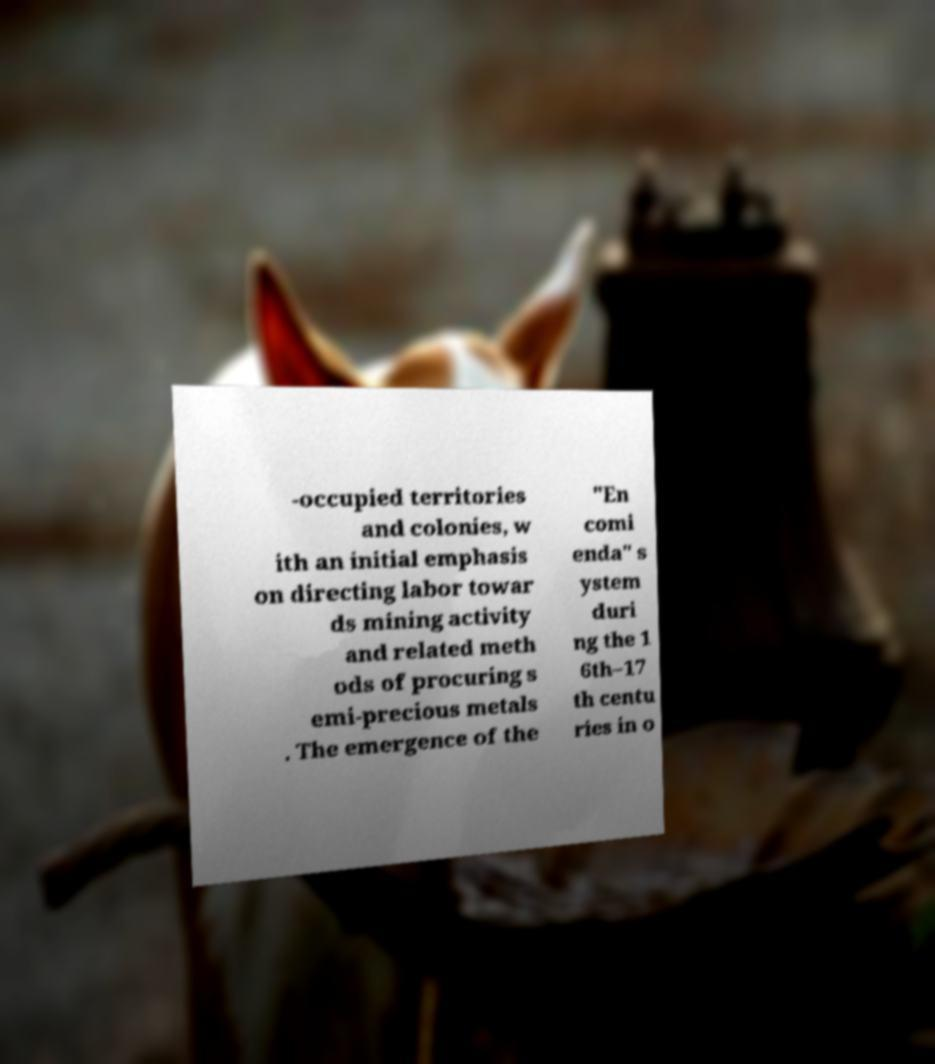Could you extract and type out the text from this image? -occupied territories and colonies, w ith an initial emphasis on directing labor towar ds mining activity and related meth ods of procuring s emi-precious metals . The emergence of the "En comi enda" s ystem duri ng the 1 6th–17 th centu ries in o 